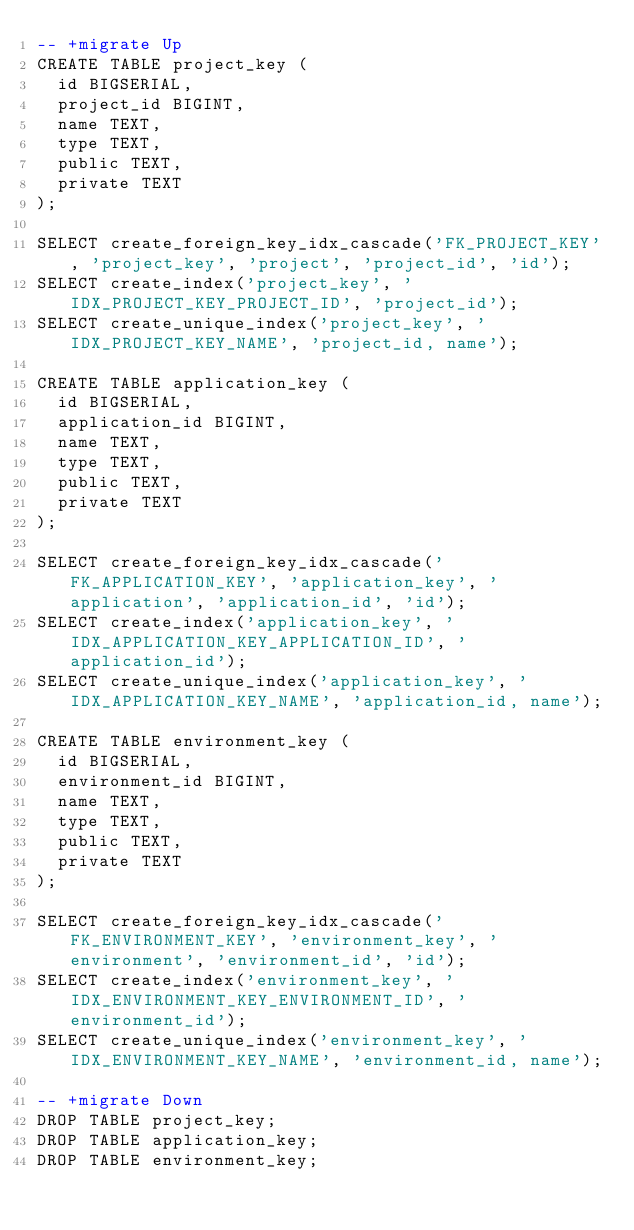Convert code to text. <code><loc_0><loc_0><loc_500><loc_500><_SQL_>-- +migrate Up
CREATE TABLE project_key (
  id BIGSERIAL,
  project_id BIGINT,
  name TEXT,
  type TEXT,
  public TEXT,
  private TEXT
);

SELECT create_foreign_key_idx_cascade('FK_PROJECT_KEY', 'project_key', 'project', 'project_id', 'id');
SELECT create_index('project_key', 'IDX_PROJECT_KEY_PROJECT_ID', 'project_id');
SELECT create_unique_index('project_key', 'IDX_PROJECT_KEY_NAME', 'project_id, name');

CREATE TABLE application_key (
  id BIGSERIAL,
  application_id BIGINT,
  name TEXT,
  type TEXT,
  public TEXT,
  private TEXT
);

SELECT create_foreign_key_idx_cascade('FK_APPLICATION_KEY', 'application_key', 'application', 'application_id', 'id');
SELECT create_index('application_key', 'IDX_APPLICATION_KEY_APPLICATION_ID', 'application_id');
SELECT create_unique_index('application_key', 'IDX_APPLICATION_KEY_NAME', 'application_id, name');

CREATE TABLE environment_key (
  id BIGSERIAL,
  environment_id BIGINT,
  name TEXT,
  type TEXT,
  public TEXT,
  private TEXT
);

SELECT create_foreign_key_idx_cascade('FK_ENVIRONMENT_KEY', 'environment_key', 'environment', 'environment_id', 'id');
SELECT create_index('environment_key', 'IDX_ENVIRONMENT_KEY_ENVIRONMENT_ID', 'environment_id');
SELECT create_unique_index('environment_key', 'IDX_ENVIRONMENT_KEY_NAME', 'environment_id, name');

-- +migrate Down
DROP TABLE project_key;
DROP TABLE application_key;
DROP TABLE environment_key;

</code> 